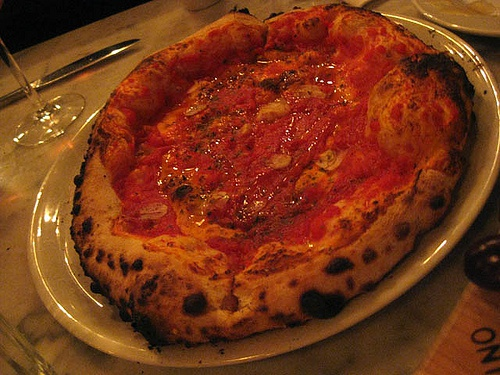Describe the objects in this image and their specific colors. I can see pizza in maroon, brown, and black tones, wine glass in maroon, olive, and black tones, and knife in maroon, black, and olive tones in this image. 